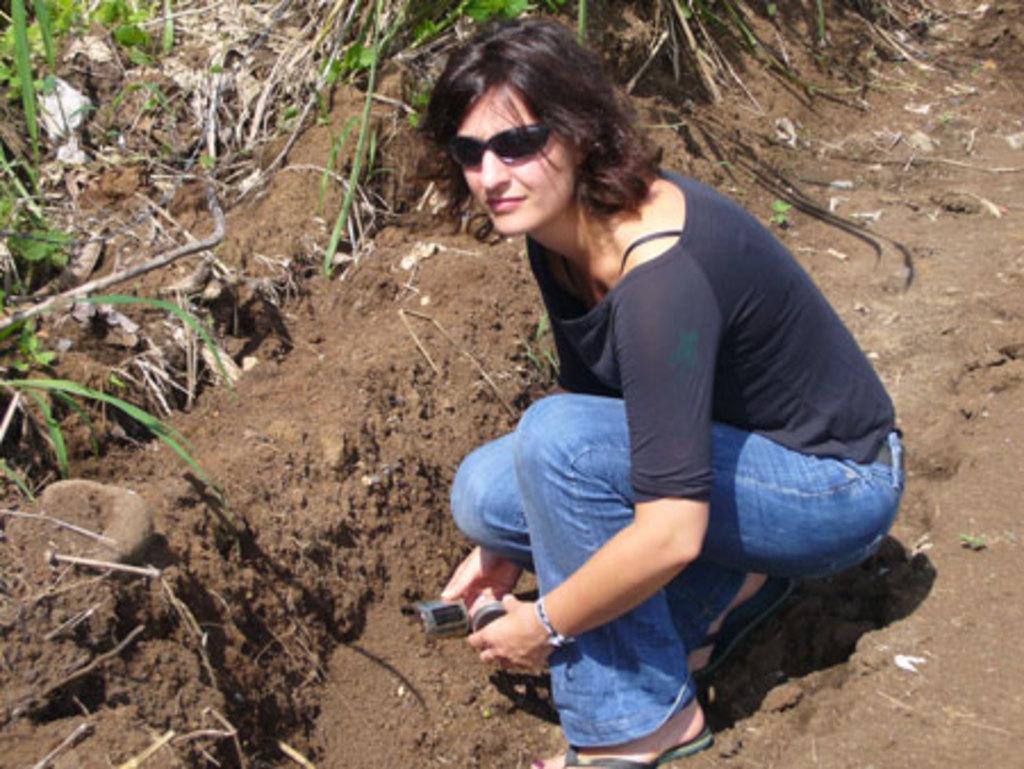In one or two sentences, can you explain what this image depicts? In this image I can see a woman wearing black colored t shirt, blue jeans and footwear is sitting and holding an object in her hand. In the background I can see the ground, some grass and a rock. 